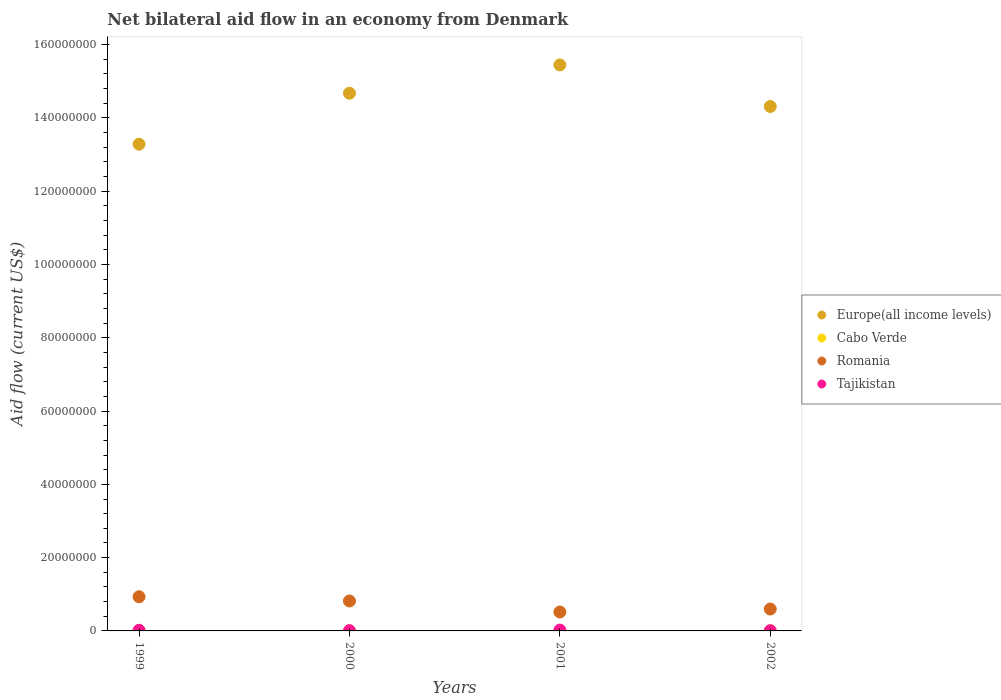How many different coloured dotlines are there?
Give a very brief answer. 4. Is the number of dotlines equal to the number of legend labels?
Keep it short and to the point. No. What is the net bilateral aid flow in Romania in 2000?
Offer a terse response. 8.17e+06. Across all years, what is the maximum net bilateral aid flow in Europe(all income levels)?
Provide a succinct answer. 1.54e+08. Across all years, what is the minimum net bilateral aid flow in Romania?
Your response must be concise. 5.17e+06. In which year was the net bilateral aid flow in Tajikistan maximum?
Make the answer very short. 2001. What is the total net bilateral aid flow in Tajikistan in the graph?
Keep it short and to the point. 5.40e+05. What is the difference between the net bilateral aid flow in Europe(all income levels) in 2000 and that in 2002?
Offer a terse response. 3.63e+06. What is the average net bilateral aid flow in Romania per year?
Provide a short and direct response. 7.16e+06. In the year 1999, what is the difference between the net bilateral aid flow in Tajikistan and net bilateral aid flow in Romania?
Provide a succinct answer. -9.15e+06. What is the ratio of the net bilateral aid flow in Tajikistan in 2001 to that in 2002?
Offer a terse response. 3.83. What is the difference between the highest and the lowest net bilateral aid flow in Romania?
Your answer should be compact. 4.16e+06. Is the sum of the net bilateral aid flow in Tajikistan in 1999 and 2000 greater than the maximum net bilateral aid flow in Romania across all years?
Give a very brief answer. No. Does the net bilateral aid flow in Tajikistan monotonically increase over the years?
Provide a short and direct response. No. What is the difference between two consecutive major ticks on the Y-axis?
Ensure brevity in your answer.  2.00e+07. Does the graph contain any zero values?
Provide a succinct answer. Yes. Where does the legend appear in the graph?
Your answer should be compact. Center right. How many legend labels are there?
Provide a short and direct response. 4. What is the title of the graph?
Keep it short and to the point. Net bilateral aid flow in an economy from Denmark. What is the label or title of the Y-axis?
Provide a short and direct response. Aid flow (current US$). What is the Aid flow (current US$) in Europe(all income levels) in 1999?
Provide a short and direct response. 1.33e+08. What is the Aid flow (current US$) in Cabo Verde in 1999?
Offer a very short reply. 7.00e+04. What is the Aid flow (current US$) of Romania in 1999?
Your response must be concise. 9.33e+06. What is the Aid flow (current US$) of Tajikistan in 1999?
Offer a terse response. 1.80e+05. What is the Aid flow (current US$) of Europe(all income levels) in 2000?
Offer a very short reply. 1.47e+08. What is the Aid flow (current US$) of Romania in 2000?
Provide a short and direct response. 8.17e+06. What is the Aid flow (current US$) in Europe(all income levels) in 2001?
Ensure brevity in your answer.  1.54e+08. What is the Aid flow (current US$) of Romania in 2001?
Provide a succinct answer. 5.17e+06. What is the Aid flow (current US$) of Tajikistan in 2001?
Your answer should be very brief. 2.30e+05. What is the Aid flow (current US$) in Europe(all income levels) in 2002?
Your answer should be compact. 1.43e+08. What is the Aid flow (current US$) in Romania in 2002?
Make the answer very short. 5.97e+06. What is the Aid flow (current US$) in Tajikistan in 2002?
Give a very brief answer. 6.00e+04. Across all years, what is the maximum Aid flow (current US$) in Europe(all income levels)?
Give a very brief answer. 1.54e+08. Across all years, what is the maximum Aid flow (current US$) of Romania?
Make the answer very short. 9.33e+06. Across all years, what is the maximum Aid flow (current US$) of Tajikistan?
Give a very brief answer. 2.30e+05. Across all years, what is the minimum Aid flow (current US$) in Europe(all income levels)?
Give a very brief answer. 1.33e+08. Across all years, what is the minimum Aid flow (current US$) in Romania?
Offer a terse response. 5.17e+06. What is the total Aid flow (current US$) of Europe(all income levels) in the graph?
Offer a terse response. 5.77e+08. What is the total Aid flow (current US$) of Romania in the graph?
Ensure brevity in your answer.  2.86e+07. What is the total Aid flow (current US$) in Tajikistan in the graph?
Provide a succinct answer. 5.40e+05. What is the difference between the Aid flow (current US$) of Europe(all income levels) in 1999 and that in 2000?
Give a very brief answer. -1.39e+07. What is the difference between the Aid flow (current US$) in Romania in 1999 and that in 2000?
Your answer should be compact. 1.16e+06. What is the difference between the Aid flow (current US$) in Europe(all income levels) in 1999 and that in 2001?
Your response must be concise. -2.16e+07. What is the difference between the Aid flow (current US$) in Romania in 1999 and that in 2001?
Offer a terse response. 4.16e+06. What is the difference between the Aid flow (current US$) in Tajikistan in 1999 and that in 2001?
Your answer should be very brief. -5.00e+04. What is the difference between the Aid flow (current US$) in Europe(all income levels) in 1999 and that in 2002?
Keep it short and to the point. -1.03e+07. What is the difference between the Aid flow (current US$) of Cabo Verde in 1999 and that in 2002?
Ensure brevity in your answer.  2.00e+04. What is the difference between the Aid flow (current US$) in Romania in 1999 and that in 2002?
Keep it short and to the point. 3.36e+06. What is the difference between the Aid flow (current US$) of Europe(all income levels) in 2000 and that in 2001?
Your answer should be compact. -7.72e+06. What is the difference between the Aid flow (current US$) of Europe(all income levels) in 2000 and that in 2002?
Your answer should be compact. 3.63e+06. What is the difference between the Aid flow (current US$) of Romania in 2000 and that in 2002?
Your answer should be very brief. 2.20e+06. What is the difference between the Aid flow (current US$) in Europe(all income levels) in 2001 and that in 2002?
Offer a terse response. 1.14e+07. What is the difference between the Aid flow (current US$) of Romania in 2001 and that in 2002?
Your response must be concise. -8.00e+05. What is the difference between the Aid flow (current US$) in Europe(all income levels) in 1999 and the Aid flow (current US$) in Cabo Verde in 2000?
Offer a very short reply. 1.33e+08. What is the difference between the Aid flow (current US$) of Europe(all income levels) in 1999 and the Aid flow (current US$) of Romania in 2000?
Your answer should be compact. 1.25e+08. What is the difference between the Aid flow (current US$) of Europe(all income levels) in 1999 and the Aid flow (current US$) of Tajikistan in 2000?
Your answer should be compact. 1.33e+08. What is the difference between the Aid flow (current US$) in Cabo Verde in 1999 and the Aid flow (current US$) in Romania in 2000?
Keep it short and to the point. -8.10e+06. What is the difference between the Aid flow (current US$) in Romania in 1999 and the Aid flow (current US$) in Tajikistan in 2000?
Make the answer very short. 9.26e+06. What is the difference between the Aid flow (current US$) in Europe(all income levels) in 1999 and the Aid flow (current US$) in Romania in 2001?
Your answer should be very brief. 1.28e+08. What is the difference between the Aid flow (current US$) of Europe(all income levels) in 1999 and the Aid flow (current US$) of Tajikistan in 2001?
Provide a short and direct response. 1.33e+08. What is the difference between the Aid flow (current US$) in Cabo Verde in 1999 and the Aid flow (current US$) in Romania in 2001?
Your answer should be very brief. -5.10e+06. What is the difference between the Aid flow (current US$) in Cabo Verde in 1999 and the Aid flow (current US$) in Tajikistan in 2001?
Your answer should be very brief. -1.60e+05. What is the difference between the Aid flow (current US$) of Romania in 1999 and the Aid flow (current US$) of Tajikistan in 2001?
Your answer should be compact. 9.10e+06. What is the difference between the Aid flow (current US$) in Europe(all income levels) in 1999 and the Aid flow (current US$) in Cabo Verde in 2002?
Keep it short and to the point. 1.33e+08. What is the difference between the Aid flow (current US$) in Europe(all income levels) in 1999 and the Aid flow (current US$) in Romania in 2002?
Provide a short and direct response. 1.27e+08. What is the difference between the Aid flow (current US$) of Europe(all income levels) in 1999 and the Aid flow (current US$) of Tajikistan in 2002?
Provide a short and direct response. 1.33e+08. What is the difference between the Aid flow (current US$) in Cabo Verde in 1999 and the Aid flow (current US$) in Romania in 2002?
Give a very brief answer. -5.90e+06. What is the difference between the Aid flow (current US$) of Romania in 1999 and the Aid flow (current US$) of Tajikistan in 2002?
Your answer should be very brief. 9.27e+06. What is the difference between the Aid flow (current US$) in Europe(all income levels) in 2000 and the Aid flow (current US$) in Romania in 2001?
Provide a short and direct response. 1.42e+08. What is the difference between the Aid flow (current US$) in Europe(all income levels) in 2000 and the Aid flow (current US$) in Tajikistan in 2001?
Ensure brevity in your answer.  1.47e+08. What is the difference between the Aid flow (current US$) of Cabo Verde in 2000 and the Aid flow (current US$) of Romania in 2001?
Your answer should be very brief. -5.15e+06. What is the difference between the Aid flow (current US$) in Romania in 2000 and the Aid flow (current US$) in Tajikistan in 2001?
Your response must be concise. 7.94e+06. What is the difference between the Aid flow (current US$) in Europe(all income levels) in 2000 and the Aid flow (current US$) in Cabo Verde in 2002?
Your answer should be very brief. 1.47e+08. What is the difference between the Aid flow (current US$) in Europe(all income levels) in 2000 and the Aid flow (current US$) in Romania in 2002?
Offer a terse response. 1.41e+08. What is the difference between the Aid flow (current US$) in Europe(all income levels) in 2000 and the Aid flow (current US$) in Tajikistan in 2002?
Your answer should be very brief. 1.47e+08. What is the difference between the Aid flow (current US$) in Cabo Verde in 2000 and the Aid flow (current US$) in Romania in 2002?
Ensure brevity in your answer.  -5.95e+06. What is the difference between the Aid flow (current US$) in Cabo Verde in 2000 and the Aid flow (current US$) in Tajikistan in 2002?
Offer a terse response. -4.00e+04. What is the difference between the Aid flow (current US$) in Romania in 2000 and the Aid flow (current US$) in Tajikistan in 2002?
Your answer should be compact. 8.11e+06. What is the difference between the Aid flow (current US$) in Europe(all income levels) in 2001 and the Aid flow (current US$) in Cabo Verde in 2002?
Your answer should be compact. 1.54e+08. What is the difference between the Aid flow (current US$) of Europe(all income levels) in 2001 and the Aid flow (current US$) of Romania in 2002?
Offer a very short reply. 1.48e+08. What is the difference between the Aid flow (current US$) of Europe(all income levels) in 2001 and the Aid flow (current US$) of Tajikistan in 2002?
Your response must be concise. 1.54e+08. What is the difference between the Aid flow (current US$) in Romania in 2001 and the Aid flow (current US$) in Tajikistan in 2002?
Provide a short and direct response. 5.11e+06. What is the average Aid flow (current US$) in Europe(all income levels) per year?
Your answer should be compact. 1.44e+08. What is the average Aid flow (current US$) of Cabo Verde per year?
Give a very brief answer. 3.50e+04. What is the average Aid flow (current US$) in Romania per year?
Provide a short and direct response. 7.16e+06. What is the average Aid flow (current US$) of Tajikistan per year?
Keep it short and to the point. 1.35e+05. In the year 1999, what is the difference between the Aid flow (current US$) in Europe(all income levels) and Aid flow (current US$) in Cabo Verde?
Make the answer very short. 1.33e+08. In the year 1999, what is the difference between the Aid flow (current US$) in Europe(all income levels) and Aid flow (current US$) in Romania?
Your answer should be compact. 1.24e+08. In the year 1999, what is the difference between the Aid flow (current US$) in Europe(all income levels) and Aid flow (current US$) in Tajikistan?
Provide a succinct answer. 1.33e+08. In the year 1999, what is the difference between the Aid flow (current US$) of Cabo Verde and Aid flow (current US$) of Romania?
Provide a succinct answer. -9.26e+06. In the year 1999, what is the difference between the Aid flow (current US$) in Romania and Aid flow (current US$) in Tajikistan?
Your response must be concise. 9.15e+06. In the year 2000, what is the difference between the Aid flow (current US$) of Europe(all income levels) and Aid flow (current US$) of Cabo Verde?
Give a very brief answer. 1.47e+08. In the year 2000, what is the difference between the Aid flow (current US$) of Europe(all income levels) and Aid flow (current US$) of Romania?
Make the answer very short. 1.39e+08. In the year 2000, what is the difference between the Aid flow (current US$) of Europe(all income levels) and Aid flow (current US$) of Tajikistan?
Provide a short and direct response. 1.47e+08. In the year 2000, what is the difference between the Aid flow (current US$) of Cabo Verde and Aid flow (current US$) of Romania?
Your answer should be very brief. -8.15e+06. In the year 2000, what is the difference between the Aid flow (current US$) in Cabo Verde and Aid flow (current US$) in Tajikistan?
Provide a short and direct response. -5.00e+04. In the year 2000, what is the difference between the Aid flow (current US$) in Romania and Aid flow (current US$) in Tajikistan?
Provide a succinct answer. 8.10e+06. In the year 2001, what is the difference between the Aid flow (current US$) in Europe(all income levels) and Aid flow (current US$) in Romania?
Provide a succinct answer. 1.49e+08. In the year 2001, what is the difference between the Aid flow (current US$) of Europe(all income levels) and Aid flow (current US$) of Tajikistan?
Offer a very short reply. 1.54e+08. In the year 2001, what is the difference between the Aid flow (current US$) of Romania and Aid flow (current US$) of Tajikistan?
Your response must be concise. 4.94e+06. In the year 2002, what is the difference between the Aid flow (current US$) of Europe(all income levels) and Aid flow (current US$) of Cabo Verde?
Ensure brevity in your answer.  1.43e+08. In the year 2002, what is the difference between the Aid flow (current US$) in Europe(all income levels) and Aid flow (current US$) in Romania?
Offer a very short reply. 1.37e+08. In the year 2002, what is the difference between the Aid flow (current US$) of Europe(all income levels) and Aid flow (current US$) of Tajikistan?
Provide a succinct answer. 1.43e+08. In the year 2002, what is the difference between the Aid flow (current US$) of Cabo Verde and Aid flow (current US$) of Romania?
Offer a terse response. -5.92e+06. In the year 2002, what is the difference between the Aid flow (current US$) in Cabo Verde and Aid flow (current US$) in Tajikistan?
Your answer should be compact. -10000. In the year 2002, what is the difference between the Aid flow (current US$) of Romania and Aid flow (current US$) of Tajikistan?
Ensure brevity in your answer.  5.91e+06. What is the ratio of the Aid flow (current US$) in Europe(all income levels) in 1999 to that in 2000?
Ensure brevity in your answer.  0.91. What is the ratio of the Aid flow (current US$) in Cabo Verde in 1999 to that in 2000?
Provide a succinct answer. 3.5. What is the ratio of the Aid flow (current US$) in Romania in 1999 to that in 2000?
Give a very brief answer. 1.14. What is the ratio of the Aid flow (current US$) in Tajikistan in 1999 to that in 2000?
Your answer should be compact. 2.57. What is the ratio of the Aid flow (current US$) in Europe(all income levels) in 1999 to that in 2001?
Your answer should be compact. 0.86. What is the ratio of the Aid flow (current US$) of Romania in 1999 to that in 2001?
Give a very brief answer. 1.8. What is the ratio of the Aid flow (current US$) in Tajikistan in 1999 to that in 2001?
Keep it short and to the point. 0.78. What is the ratio of the Aid flow (current US$) in Europe(all income levels) in 1999 to that in 2002?
Provide a succinct answer. 0.93. What is the ratio of the Aid flow (current US$) in Cabo Verde in 1999 to that in 2002?
Provide a short and direct response. 1.4. What is the ratio of the Aid flow (current US$) in Romania in 1999 to that in 2002?
Provide a succinct answer. 1.56. What is the ratio of the Aid flow (current US$) in Tajikistan in 1999 to that in 2002?
Give a very brief answer. 3. What is the ratio of the Aid flow (current US$) in Romania in 2000 to that in 2001?
Give a very brief answer. 1.58. What is the ratio of the Aid flow (current US$) of Tajikistan in 2000 to that in 2001?
Make the answer very short. 0.3. What is the ratio of the Aid flow (current US$) in Europe(all income levels) in 2000 to that in 2002?
Your answer should be very brief. 1.03. What is the ratio of the Aid flow (current US$) of Romania in 2000 to that in 2002?
Provide a short and direct response. 1.37. What is the ratio of the Aid flow (current US$) in Tajikistan in 2000 to that in 2002?
Offer a very short reply. 1.17. What is the ratio of the Aid flow (current US$) in Europe(all income levels) in 2001 to that in 2002?
Make the answer very short. 1.08. What is the ratio of the Aid flow (current US$) of Romania in 2001 to that in 2002?
Ensure brevity in your answer.  0.87. What is the ratio of the Aid flow (current US$) of Tajikistan in 2001 to that in 2002?
Offer a terse response. 3.83. What is the difference between the highest and the second highest Aid flow (current US$) in Europe(all income levels)?
Make the answer very short. 7.72e+06. What is the difference between the highest and the second highest Aid flow (current US$) of Cabo Verde?
Provide a short and direct response. 2.00e+04. What is the difference between the highest and the second highest Aid flow (current US$) in Romania?
Your answer should be compact. 1.16e+06. What is the difference between the highest and the second highest Aid flow (current US$) of Tajikistan?
Your answer should be compact. 5.00e+04. What is the difference between the highest and the lowest Aid flow (current US$) in Europe(all income levels)?
Provide a short and direct response. 2.16e+07. What is the difference between the highest and the lowest Aid flow (current US$) in Romania?
Make the answer very short. 4.16e+06. What is the difference between the highest and the lowest Aid flow (current US$) in Tajikistan?
Provide a succinct answer. 1.70e+05. 